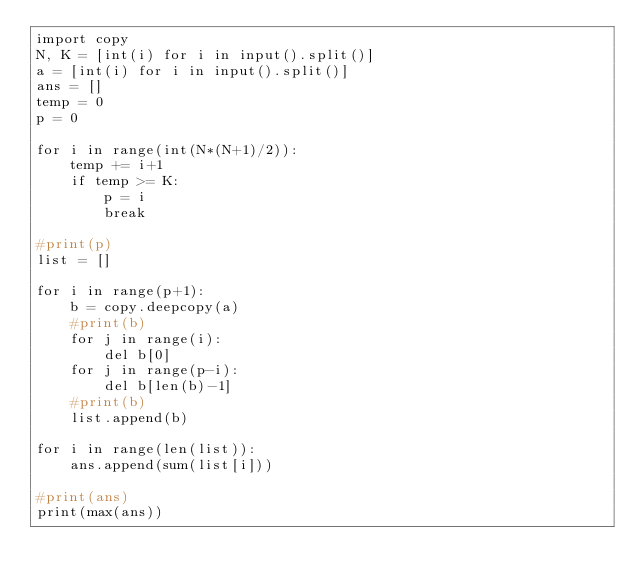Convert code to text. <code><loc_0><loc_0><loc_500><loc_500><_Python_>import copy
N, K = [int(i) for i in input().split()]
a = [int(i) for i in input().split()]
ans = []
temp = 0
p = 0

for i in range(int(N*(N+1)/2)):
    temp += i+1
    if temp >= K:
        p = i
        break

#print(p)
list = []

for i in range(p+1):
    b = copy.deepcopy(a)
    #print(b)
    for j in range(i):
        del b[0]
    for j in range(p-i):
        del b[len(b)-1]
    #print(b)
    list.append(b)

for i in range(len(list)):
    ans.append(sum(list[i]))

#print(ans)
print(max(ans))</code> 